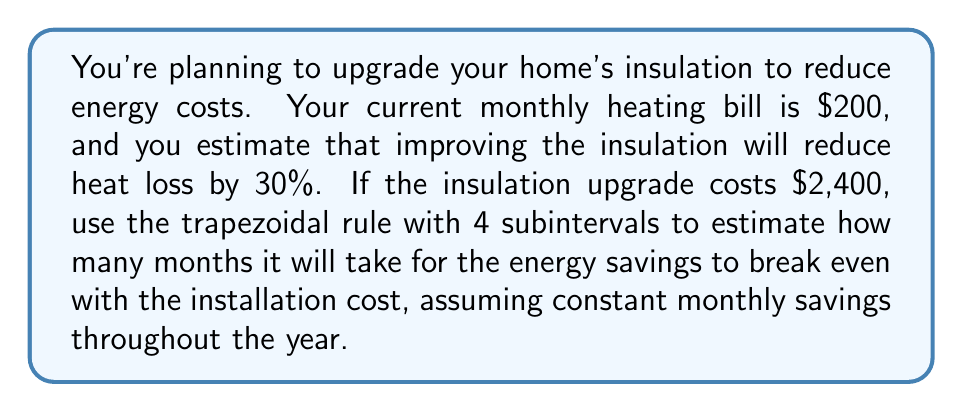Teach me how to tackle this problem. Let's approach this step-by-step:

1) First, calculate the monthly savings:
   $200 * 30% = $60 per month

2) We need to find when the cumulative savings equal the installation cost:
   $2,400 = $60 * x, where x is the number of months

3) We can set up an integral to represent the cumulative savings over time:
   $\int_0^x 60 dt = 2400$

4) To solve this using the trapezoidal rule with 4 subintervals, we need to set up our function and apply the formula:

   $f(t) = 60$ (constant function)
   
   Trapezoidal rule: $\int_a^b f(x)dx \approx \frac{h}{2}[f(x_0) + 2f(x_1) + 2f(x_2) + 2f(x_3) + f(x_4)]$

   Where $h = \frac{b-a}{n}$, $n = 4$ (number of subintervals), and $x_i = a + ih$

5) We don't know the upper limit (x) yet, so let's call it b. Then:

   $h = \frac{b-0}{4} = \frac{b}{4}$

6) Applying the trapezoidal rule:

   $2400 \approx \frac{b/4}{2}[60 + 2(60) + 2(60) + 2(60) + 60]$
   
   $2400 \approx \frac{b}{8}[60 + 120 + 120 + 120 + 60]$
   
   $2400 \approx \frac{b}{8}[480]$
   
   $2400 \approx 60b$

7) Solving for b:

   $b \approx \frac{2400}{60} = 40$

Therefore, it will take approximately 40 months for the energy savings to break even with the installation cost.
Answer: Approximately 40 months 